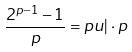Convert formula to latex. <formula><loc_0><loc_0><loc_500><loc_500>\frac { 2 ^ { p - 1 } - 1 } { p } = p u | \cdot p</formula> 